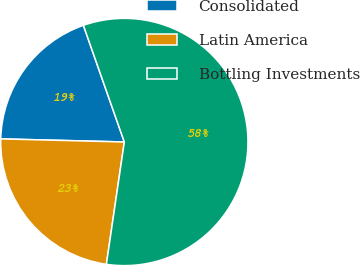Convert chart to OTSL. <chart><loc_0><loc_0><loc_500><loc_500><pie_chart><fcel>Consolidated<fcel>Latin America<fcel>Bottling Investments<nl><fcel>19.23%<fcel>23.08%<fcel>57.69%<nl></chart> 